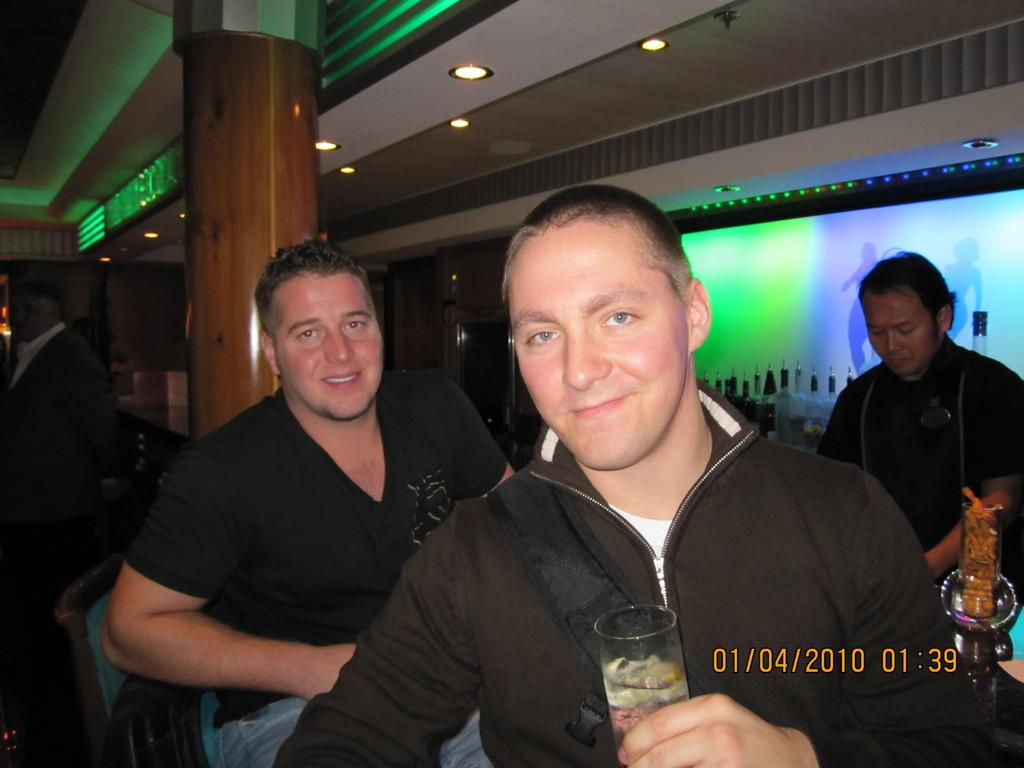How many men are in the foreground of the image? There are two men in the foreground of the image. What is located behind the two men in the image? There is a pillar behind the two men. Where is the third man located in the image? There is a man on the right side of the image. What can be seen behind the man on the right side? There are bottles behind the man on the right side. What grade is the man on the right side of the image in? There is no indication of the man's grade in the image. Can you hear the man on the right side sneeze in the image? There is no indication of sound or sneezing in the image. 